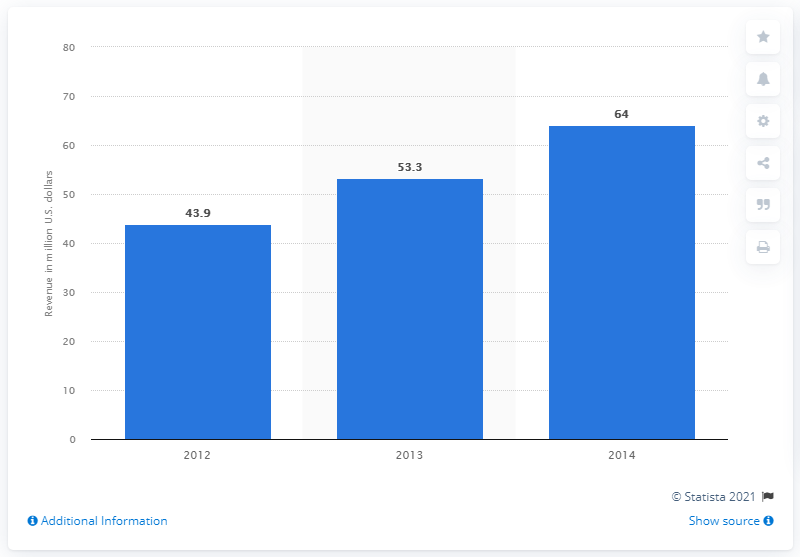Specify some key components in this picture. The projected revenue for PC online games in the Philippines from 2012 to 2014 was estimated to be 64 million US dollars. 